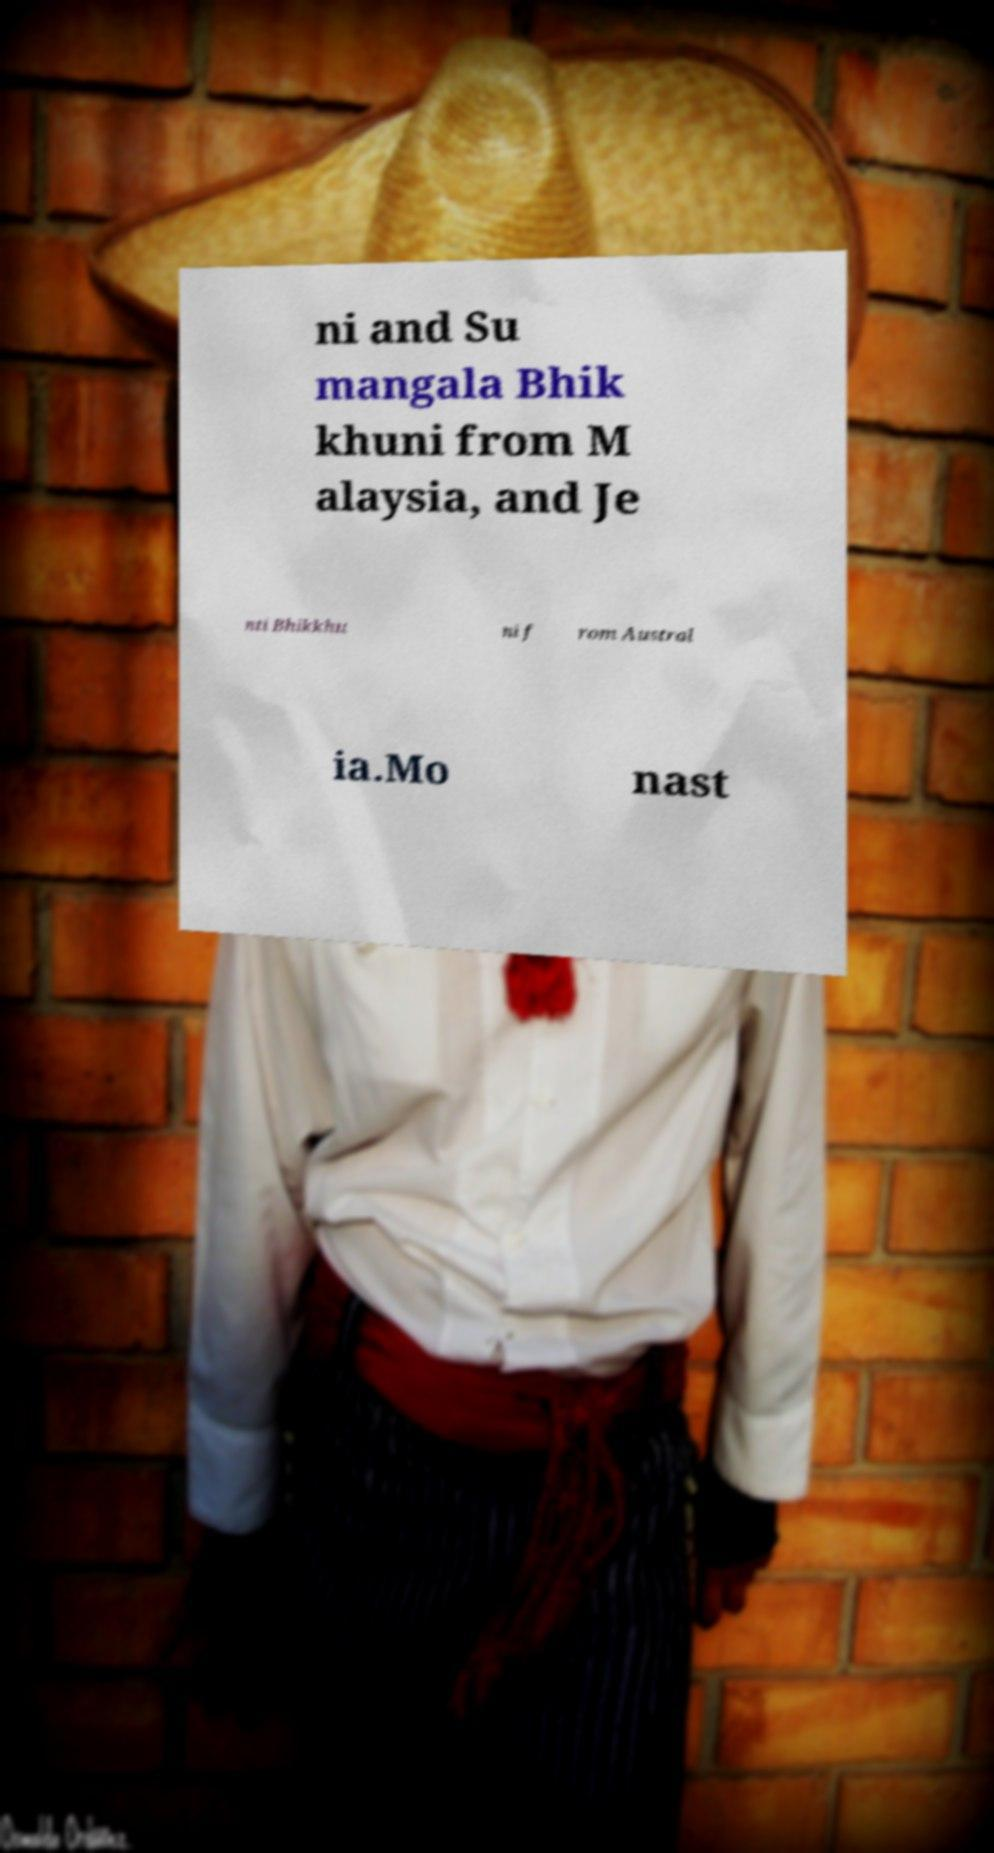Could you assist in decoding the text presented in this image and type it out clearly? ni and Su mangala Bhik khuni from M alaysia, and Je nti Bhikkhu ni f rom Austral ia.Mo nast 